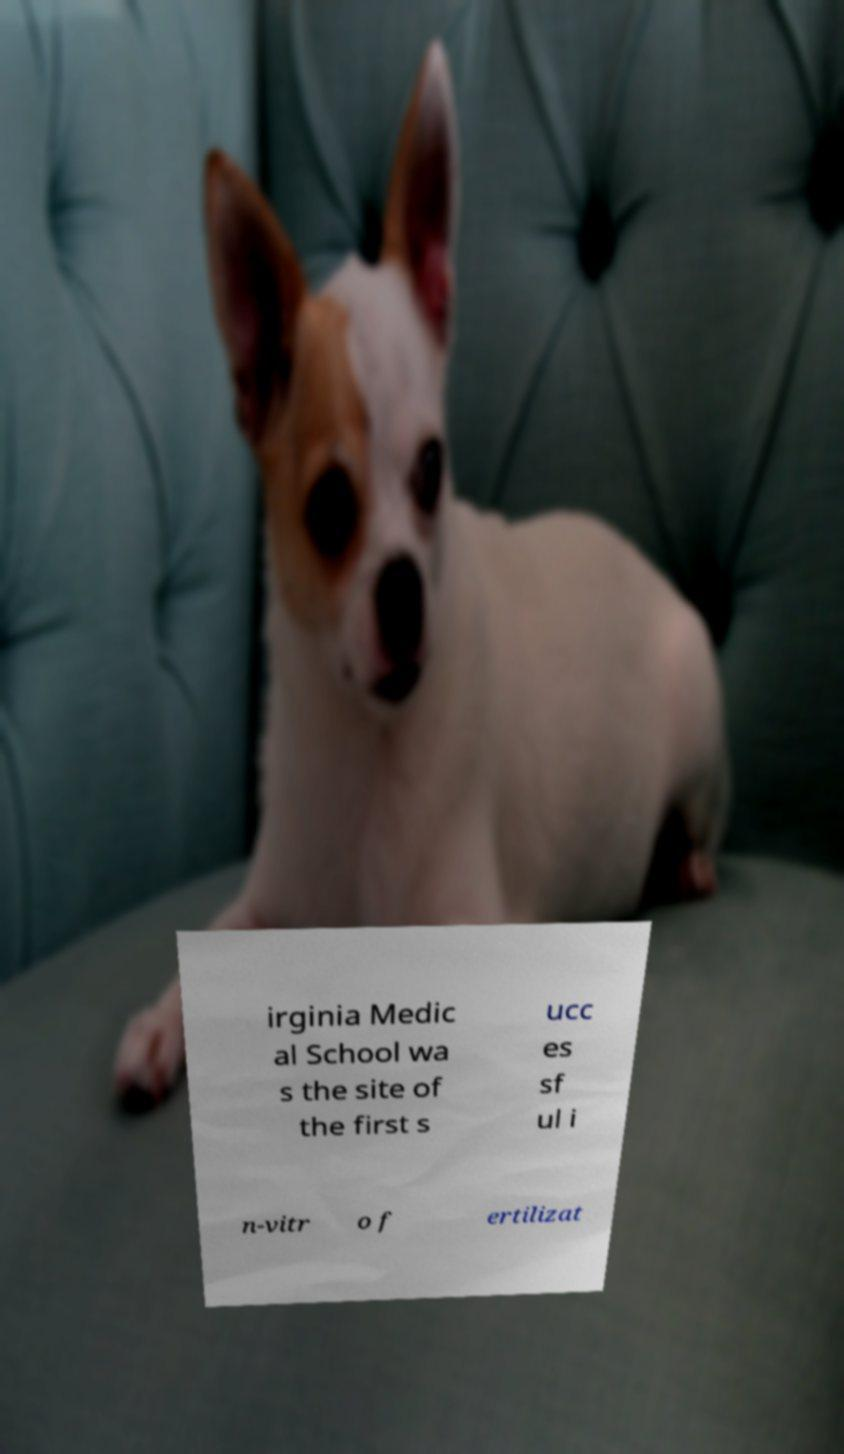There's text embedded in this image that I need extracted. Can you transcribe it verbatim? irginia Medic al School wa s the site of the first s ucc es sf ul i n-vitr o f ertilizat 